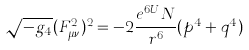Convert formula to latex. <formula><loc_0><loc_0><loc_500><loc_500>\sqrt { - g _ { 4 } } ( F _ { \mu \nu } ^ { 2 } ) ^ { 2 } = - 2 \frac { e ^ { 6 U } N } { r ^ { 6 } } ( p ^ { 4 } + q ^ { 4 } )</formula> 